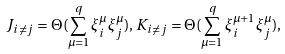Convert formula to latex. <formula><loc_0><loc_0><loc_500><loc_500>J _ { i \ne j } = \Theta ( \sum _ { \mu = 1 } ^ { q } \xi _ { i } ^ { \mu } \xi _ { j } ^ { \mu } ) , \, K _ { i \ne j } = \Theta ( \sum _ { \mu = 1 } ^ { q } \xi _ { i } ^ { \mu + 1 } \xi _ { j } ^ { \mu } ) ,</formula> 